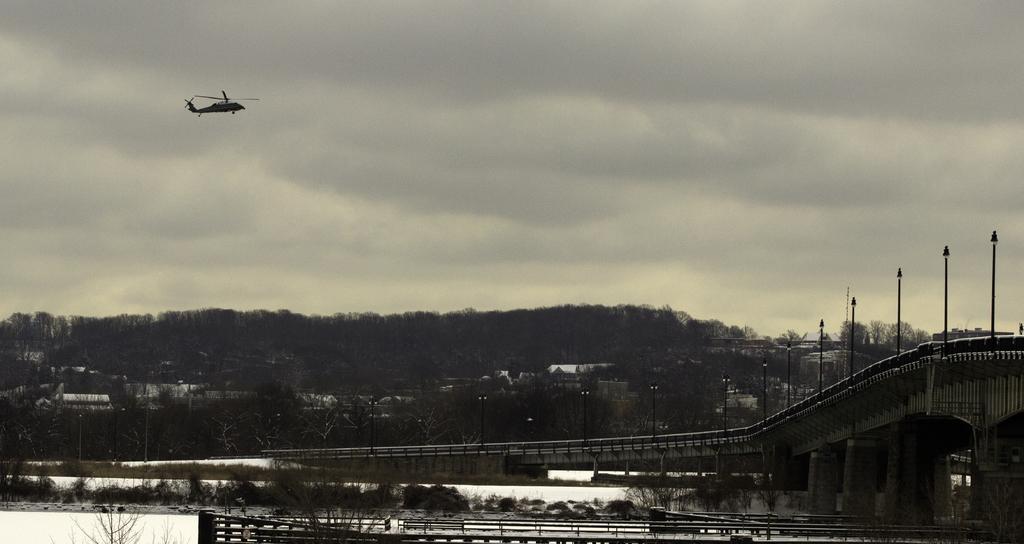Describe this image in one or two sentences. At the bottom of the image there are railings. And also there is grass on the ground. There is a bridge with walls, railings and poles with lamps. In the background there are trees. At the top of the image there is a helicopter. Behind that there is sky with clouds. 